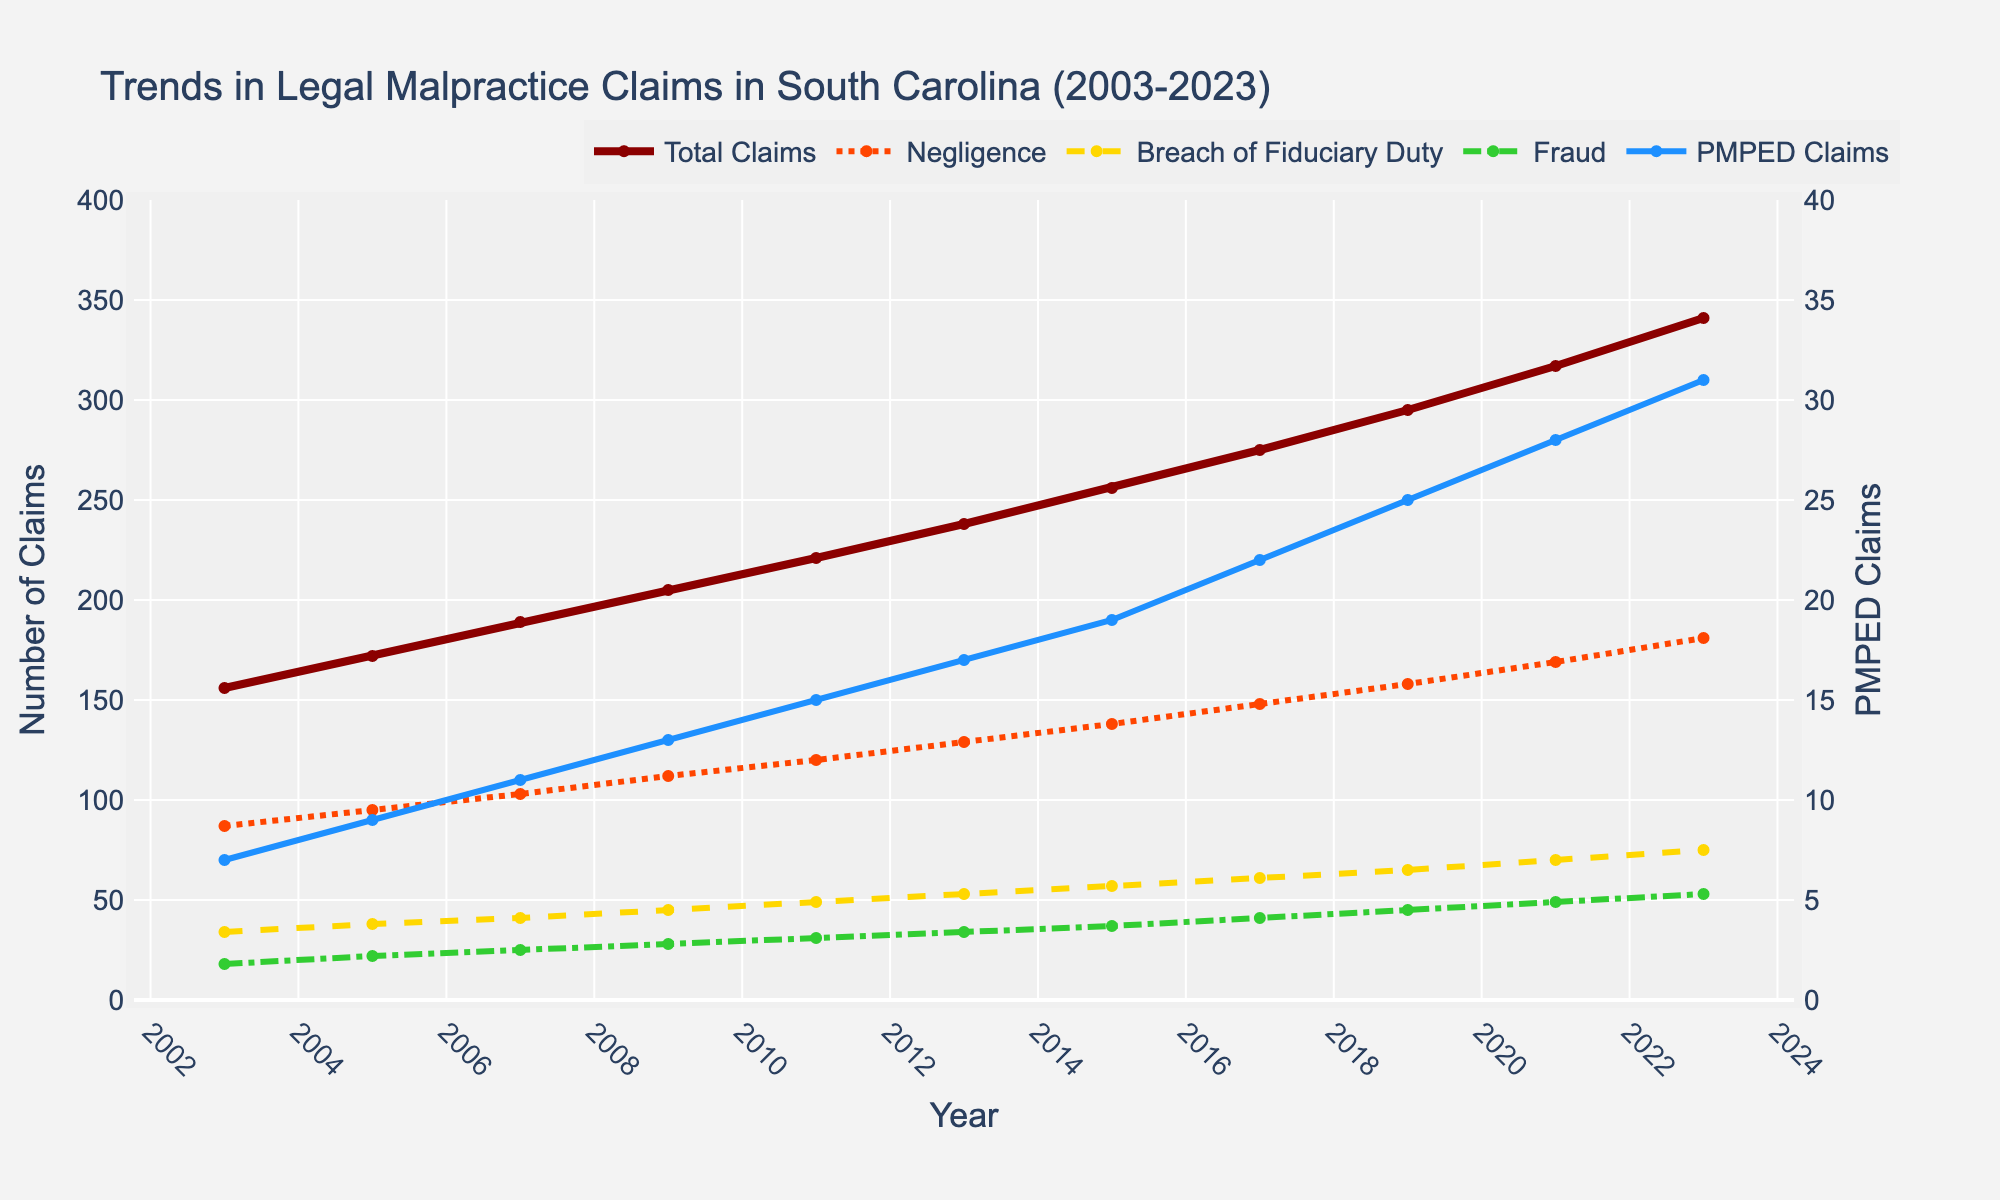What is the trend of "Total Claims" from 2003 to 2023? The trend of "Total Claims" can be observed by looking at the line representing it. From 2003 to 2023, the line for "Total Claims" is consistently increasing, indicating a positive trend over the 20-year period.
Answer: Increasing Which type of claim has the highest increase in absolute numbers from 2003 to 2023? To determine which type of claim has the highest increase, subtract the number of claims in 2003 from the number in 2023 for each type. "Total Claims" increased by 341 - 156 = 185, "Negligence" by 181 - 87 = 94, "Breach of Fiduciary Duty" by 75 - 34 = 41, "Fraud" by 53 - 18 = 35, and "PMPED Claims" by 31 - 7 = 24. "Total Claims" has the highest increase in absolute numbers.
Answer: Total Claims In which year did "Negligence" claims surpass 150 for the first time? By observing the "Negligence" line, check the year it first rises above the 150 mark. This happens somewhere between 2017 and 2019. Specifically, in 2019, "Negligence" claims are 158, being the first time it surpasses 150.
Answer: 2019 How does the number of "Fraud" claims in 2023 compare to the number of "Breach of Fiduciary Duty" claims in 2021? Compare the values of "Fraud" in 2023 (53) and "Breach of Fiduciary Duty" in 2021 (70). By visual inspection or direct comparison, "Fraud" claims in 2023 are lower than "Breach of Fiduciary Duty" claims in 2021.
Answer: Lower What is the average number of "PMPED Claims" over the 20-year period? Calculate the average by summing the "PMPED Claims" for each year and then dividing by the number of years. Sum = 7 + 9 + 11 + 13 + 15 + 17 + 19 + 22 + 25 + 28 + 31 = 197. The average is 197 / 11 = approximately 17.91.
Answer: 17.91 By how much did "Total Claims" increase between 2011 and 2017? Subtract the "Total Claims" in 2011 from those in 2017. The number of "Total Claims" in 2011 is 221, and in 2017 it is 275. So, 275 - 221 = 54.
Answer: 54 Compare the growth rates of "Negligence" and "Fraud" claims from 2003 to 2023. Which grew faster? "Negligence" grew from 87 to 181, an increase of 94. "Fraud" grew from 18 to 53, an increase of 35. To determine growth rate, use the formula (Final - Initial) / Initial. For "Negligence", the growth rate is 94 / 87 ≈ 1.08. For "Fraud", it is 35 / 18 ≈ 1.94. "Fraud" grew faster.
Answer: Fraud Are "PMPED Claims" and "Breach of Fiduciary Duty" positively correlated? To check correlation, observe if the increase/decrease pattern in "PMPED Claims" matches with "Breach of Fiduciary Duty." Both lines show a positive trend and increase over the years, implying a positive correlation.
Answer: Yes 